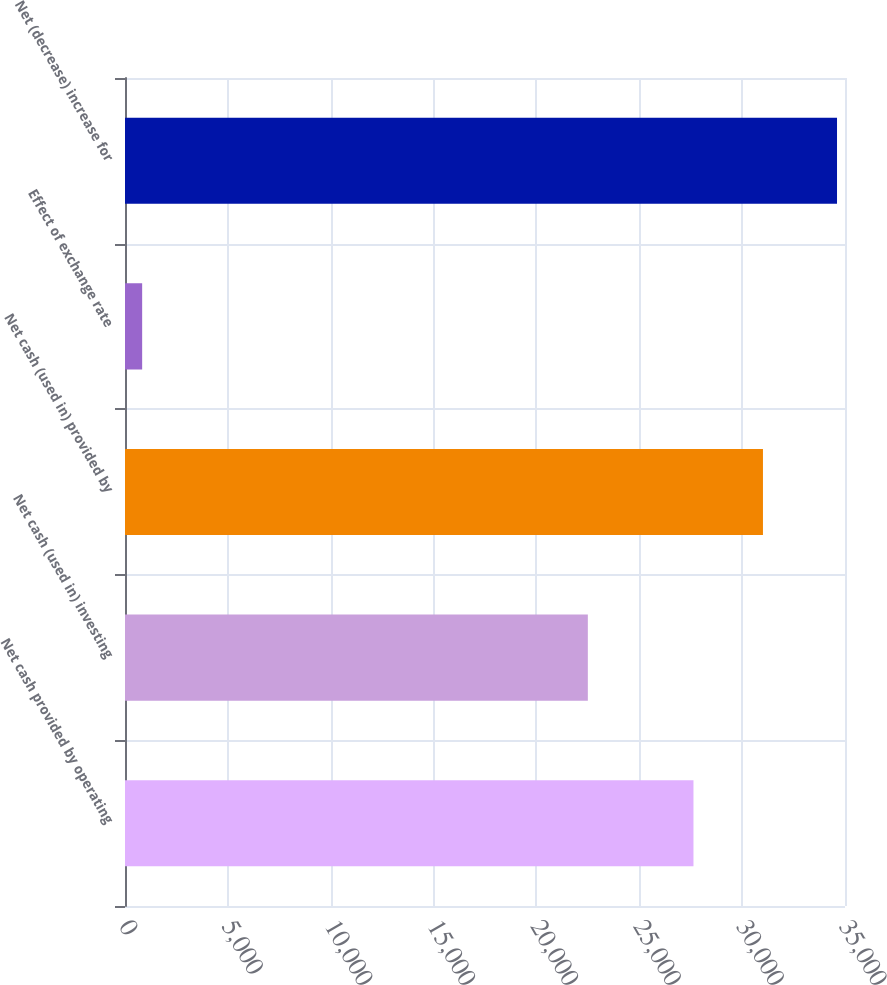Convert chart. <chart><loc_0><loc_0><loc_500><loc_500><bar_chart><fcel>Net cash provided by operating<fcel>Net cash (used in) investing<fcel>Net cash (used in) provided by<fcel>Effect of exchange rate<fcel>Net (decrease) increase for<nl><fcel>27634<fcel>22499<fcel>31011.8<fcel>834<fcel>34612<nl></chart> 